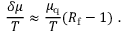Convert formula to latex. <formula><loc_0><loc_0><loc_500><loc_500>{ \frac { \delta \mu } { T } } \approx { \frac { \mu _ { q } } { T } } ( R _ { f } - 1 ) \ .</formula> 